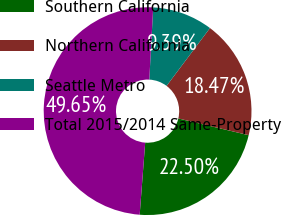Convert chart to OTSL. <chart><loc_0><loc_0><loc_500><loc_500><pie_chart><fcel>Southern California<fcel>Northern California<fcel>Seattle Metro<fcel>Total 2015/2014 Same-Property<nl><fcel>22.5%<fcel>18.47%<fcel>9.39%<fcel>49.65%<nl></chart> 